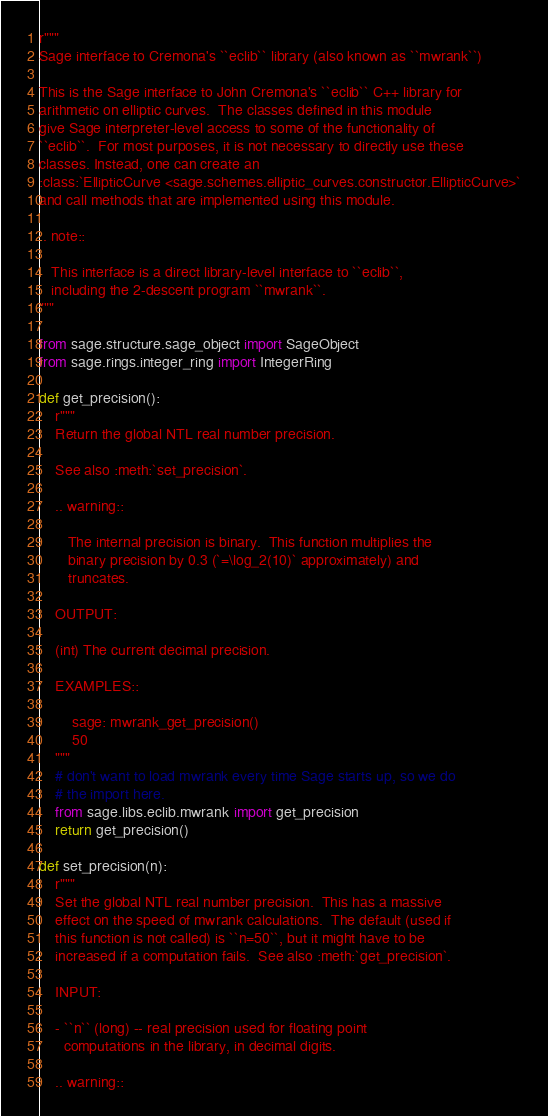<code> <loc_0><loc_0><loc_500><loc_500><_Python_>r"""
Sage interface to Cremona's ``eclib`` library (also known as ``mwrank``)

This is the Sage interface to John Cremona's ``eclib`` C++ library for
arithmetic on elliptic curves.  The classes defined in this module
give Sage interpreter-level access to some of the functionality of
``eclib``.  For most purposes, it is not necessary to directly use these
classes. Instead, one can create an
:class:`EllipticCurve <sage.schemes.elliptic_curves.constructor.EllipticCurve>`
and call methods that are implemented using this module.

.. note::

   This interface is a direct library-level interface to ``eclib``,
   including the 2-descent program ``mwrank``.
"""

from sage.structure.sage_object import SageObject
from sage.rings.integer_ring import IntegerRing

def get_precision():
    r"""
    Return the global NTL real number precision.

    See also :meth:`set_precision`.

    .. warning::

       The internal precision is binary.  This function multiplies the
       binary precision by 0.3 (`=\log_2(10)` approximately) and
       truncates.

    OUTPUT:

    (int) The current decimal precision.

    EXAMPLES::

        sage: mwrank_get_precision()
        50
    """
    # don't want to load mwrank every time Sage starts up, so we do
    # the import here.
    from sage.libs.eclib.mwrank import get_precision
    return get_precision()

def set_precision(n):
    r"""
    Set the global NTL real number precision.  This has a massive
    effect on the speed of mwrank calculations.  The default (used if
    this function is not called) is ``n=50``, but it might have to be
    increased if a computation fails.  See also :meth:`get_precision`.

    INPUT:

    - ``n`` (long) -- real precision used for floating point
      computations in the library, in decimal digits.

    .. warning::
</code> 